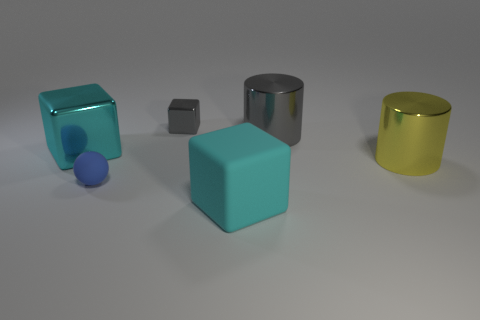Subtract 1 cubes. How many cubes are left? 2 Add 4 small blocks. How many objects exist? 10 Subtract all cylinders. How many objects are left? 4 Add 6 large cyan objects. How many large cyan objects are left? 8 Add 4 large rubber blocks. How many large rubber blocks exist? 5 Subtract 1 cyan cubes. How many objects are left? 5 Subtract all red metallic cubes. Subtract all gray things. How many objects are left? 4 